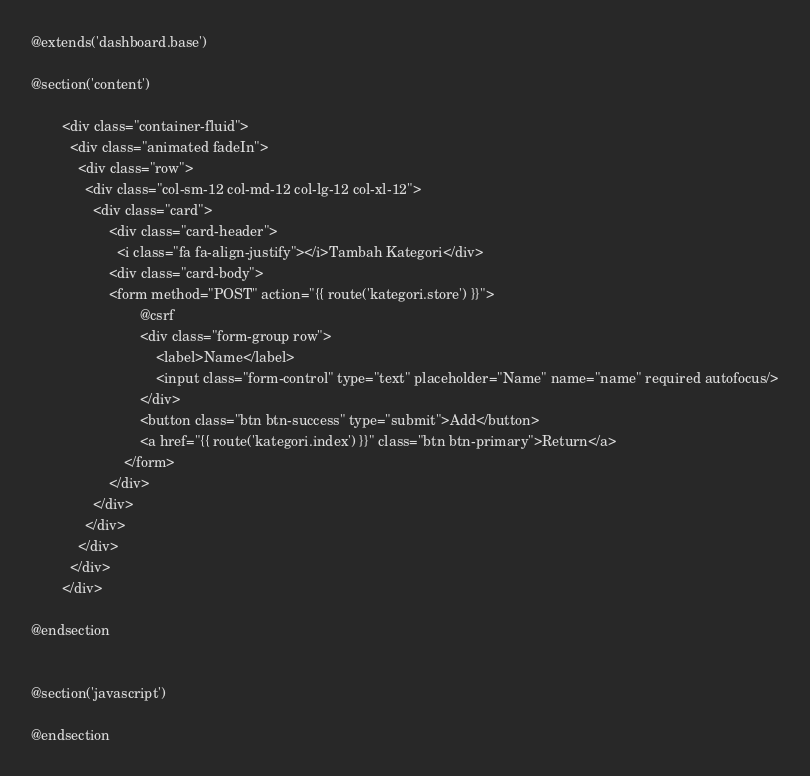<code> <loc_0><loc_0><loc_500><loc_500><_PHP_>@extends('dashboard.base')

@section('content')

        <div class="container-fluid">
          <div class="animated fadeIn">
            <div class="row">
              <div class="col-sm-12 col-md-12 col-lg-12 col-xl-12">
                <div class="card">
                    <div class="card-header">
                      <i class="fa fa-align-justify"></i>Tambah Kategori</div>
                    <div class="card-body">
                    <form method="POST" action="{{ route('kategori.store') }}">
                            @csrf
                            <div class="form-group row">
                                <label>Name</label>
                                <input class="form-control" type="text" placeholder="Name" name="name" required autofocus/>
                            </div>
                            <button class="btn btn-success" type="submit">Add</button>
                            <a href="{{ route('kategori.index') }}" class="btn btn-primary">Return</a> 
                        </form>
                    </div>
                </div>
              </div>
            </div>
          </div>
        </div>

@endsection


@section('javascript')

@endsection
</code> 